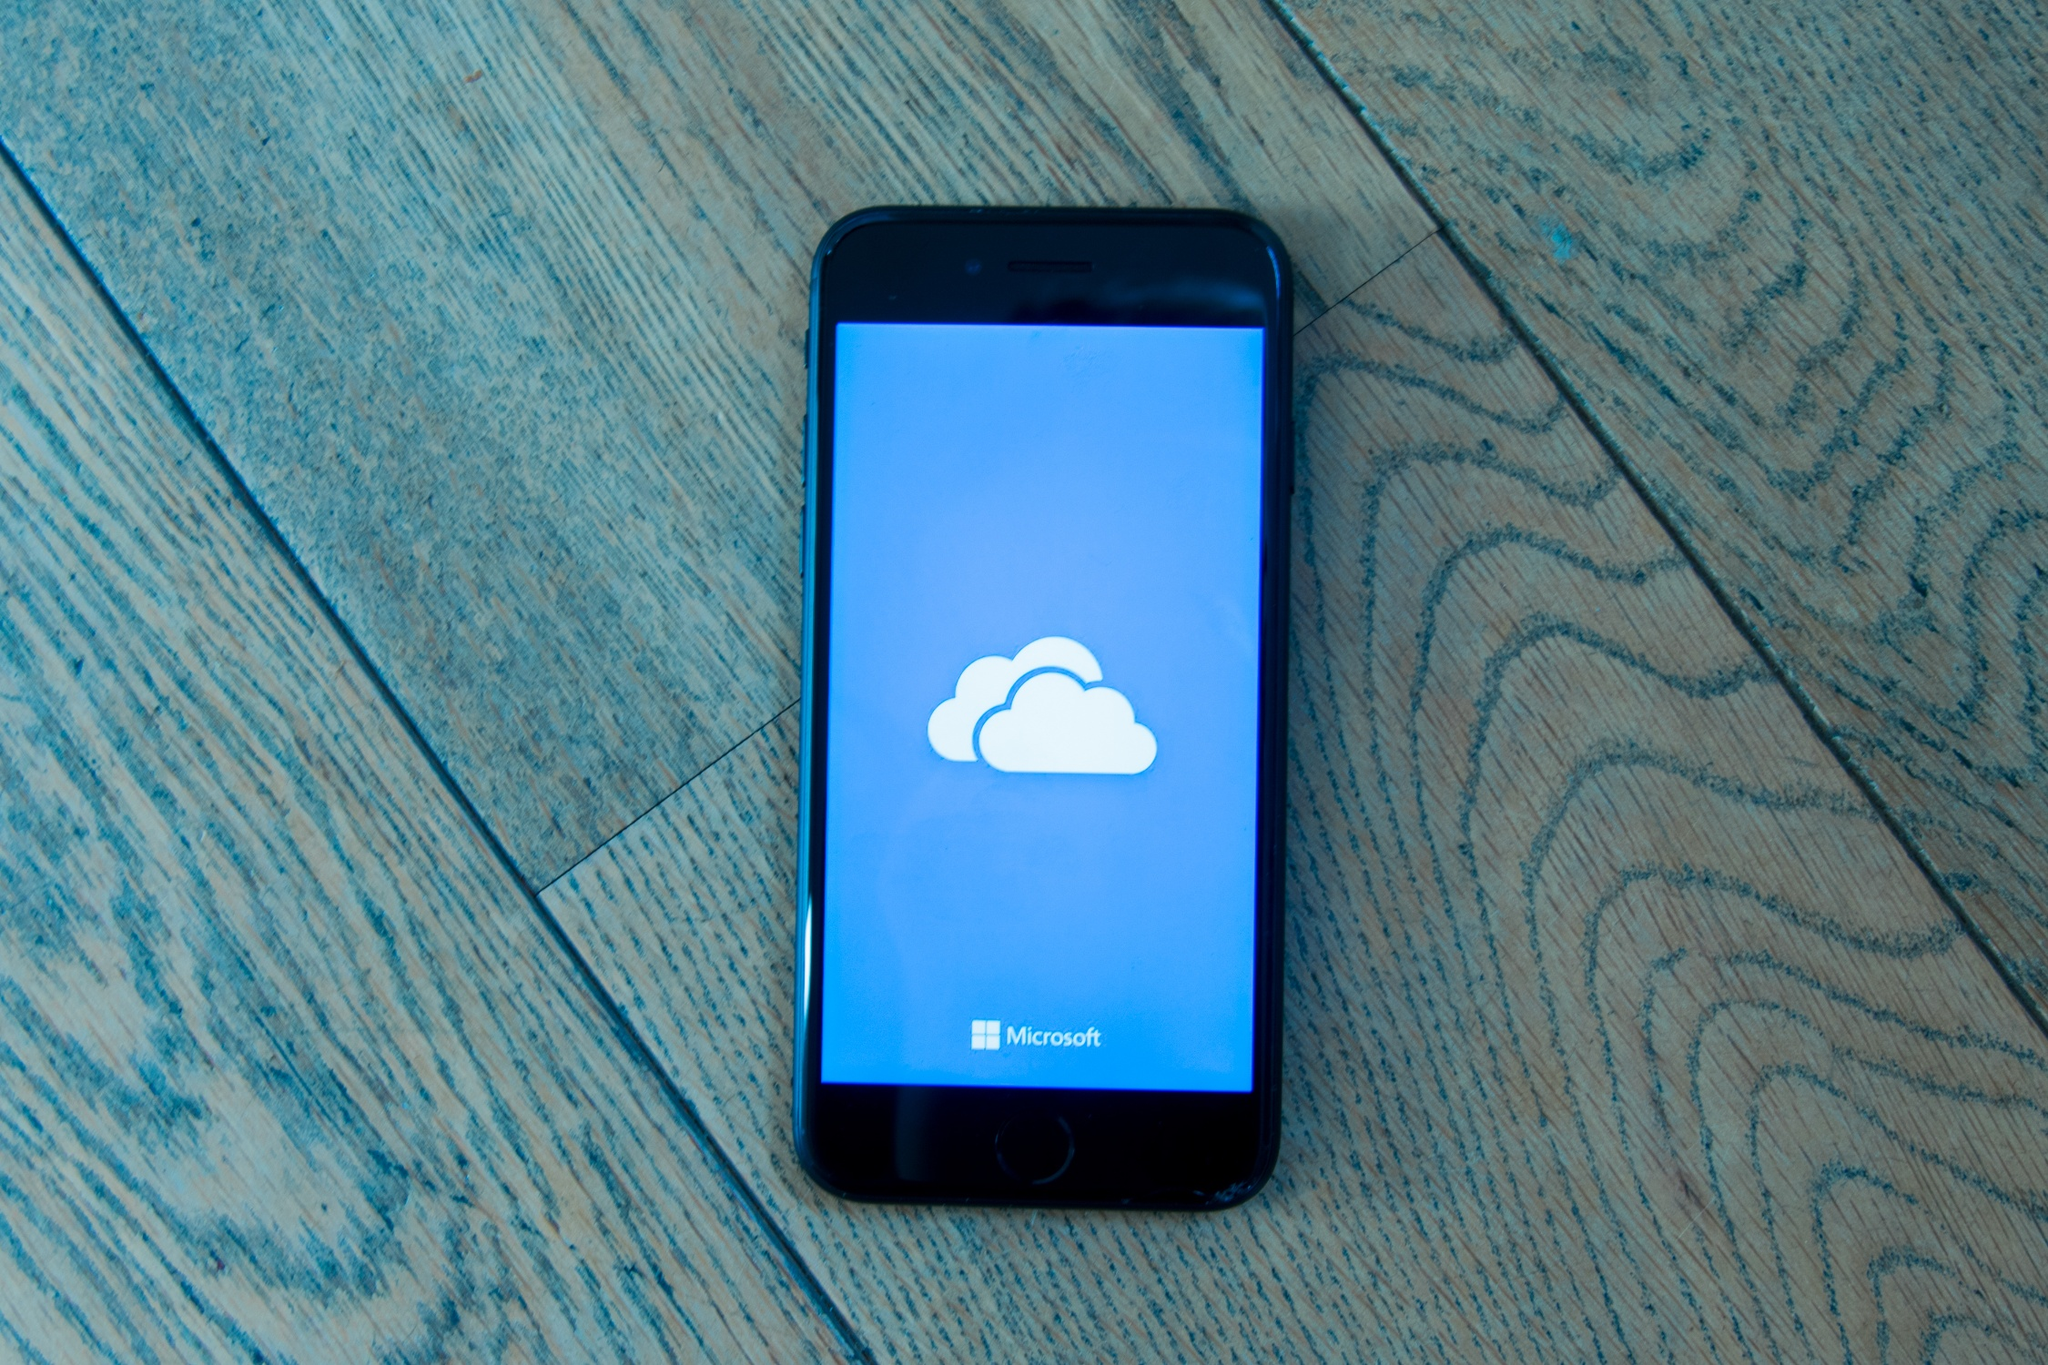If you had to turn this scene into a short story, what narrative could you create around it? In a quiet, sunlit room, Ivy hastily placed her iPhone on the wooden floor, the screen aglow with the cloud icon. She paced around, her thoughts a whirlwind. She had just uploaded the first draft of her novel to Microsoft’s cloud storage, ensuring it was safe from her mischievous cat and any potential spills of morning coffee. The phone lay there, a silent guardian of her dreams and hard work, basking under the gentle, filtered sunlight. This moment of calm and reflection amidst a whirlwind of ideas held a promise: a journey where creativity meets technology, preserving each thought in a digital haven. What elements from the image can be emphasized to give the story an emotional depth? To amplify the emotional depth of the story, elements like the warm, gentle sunlight hitting the wooden floor can be underscored, symbolizing a kind of quiet hope and inspiration. The diagonal placement of the iPhone can represent Ivy's chaotic yet promising creative process. Mentioning the floor's pattern and texture could provide grounding to her character, linking her creative efforts to her everyday environment. Additionally, the illuminated screen with Microsoft’s cloud icon can be portrayed as a beacon of her progress and dreams, emphasizing the emotional significance of preserving her novel in a digital sanctuary. 